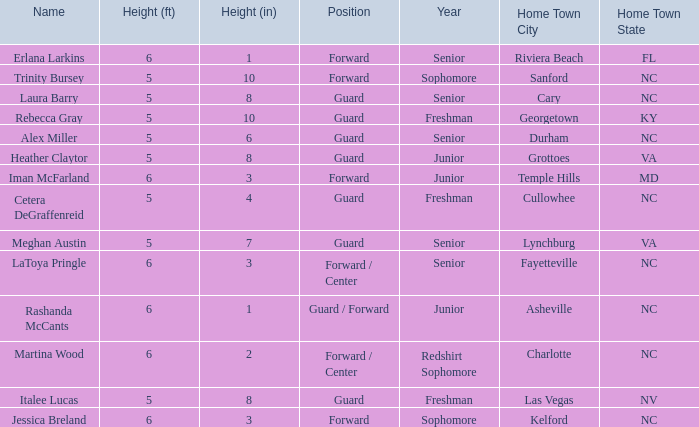What position does the 5-8 player from Grottoes, VA play? Guard. Can you give me this table as a dict? {'header': ['Name', 'Height (ft)', 'Height (in)', 'Position', 'Year', 'Home Town City', 'Home Town State'], 'rows': [['Erlana Larkins', '6', '1', 'Forward', 'Senior', 'Riviera Beach', 'FL'], ['Trinity Bursey', '5', '10', 'Forward', 'Sophomore', 'Sanford', 'NC'], ['Laura Barry', '5', '8', 'Guard', 'Senior', 'Cary', 'NC'], ['Rebecca Gray', '5', '10', 'Guard', 'Freshman', 'Georgetown', 'KY'], ['Alex Miller', '5', '6', 'Guard', 'Senior', 'Durham', 'NC'], ['Heather Claytor', '5', '8', 'Guard', 'Junior', 'Grottoes', 'VA'], ['Iman McFarland', '6', '3', 'Forward', 'Junior', 'Temple Hills', 'MD'], ['Cetera DeGraffenreid', '5', '4', 'Guard', 'Freshman', 'Cullowhee', 'NC'], ['Meghan Austin', '5', '7', 'Guard', 'Senior', 'Lynchburg', 'VA'], ['LaToya Pringle', '6', '3', 'Forward / Center', 'Senior', 'Fayetteville', 'NC'], ['Rashanda McCants', '6', '1', 'Guard / Forward', 'Junior', 'Asheville', 'NC'], ['Martina Wood', '6', '2', 'Forward / Center', 'Redshirt Sophomore', 'Charlotte', 'NC'], ['Italee Lucas', '5', '8', 'Guard', 'Freshman', 'Las Vegas', 'NV'], ['Jessica Breland', '6', '3', 'Forward', 'Sophomore', 'Kelford', 'NC']]} 